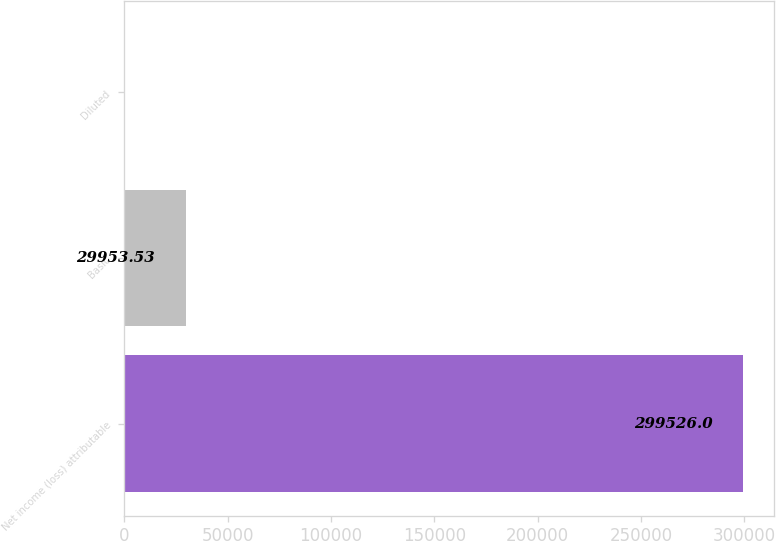<chart> <loc_0><loc_0><loc_500><loc_500><bar_chart><fcel>Net income (loss) attributable<fcel>Basic<fcel>Diluted<nl><fcel>299526<fcel>29953.5<fcel>1.03<nl></chart> 